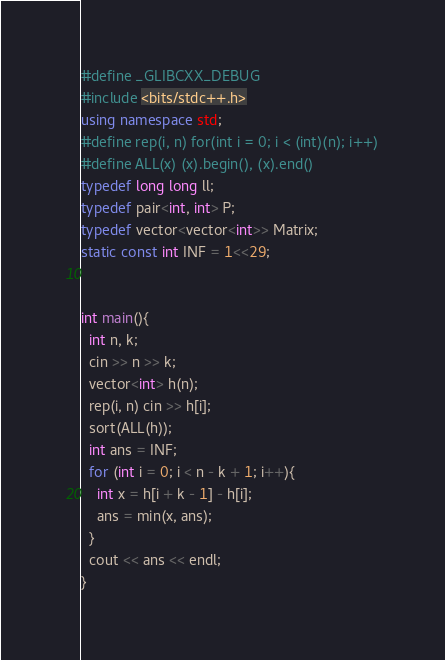Convert code to text. <code><loc_0><loc_0><loc_500><loc_500><_C++_>#define _GLIBCXX_DEBUG
#include <bits/stdc++.h>
using namespace std;
#define rep(i, n) for(int i = 0; i < (int)(n); i++)
#define ALL(x) (x).begin(), (x).end()
typedef long long ll;
typedef pair<int, int> P;
typedef vector<vector<int>> Matrix;
static const int INF = 1<<29;


int main(){
  int n, k;
  cin >> n >> k;
  vector<int> h(n);
  rep(i, n) cin >> h[i];
  sort(ALL(h));
  int ans = INF;
  for (int i = 0; i < n - k + 1; i++){
    int x = h[i + k - 1] - h[i];
    ans = min(x, ans);
  }
  cout << ans << endl;
}</code> 